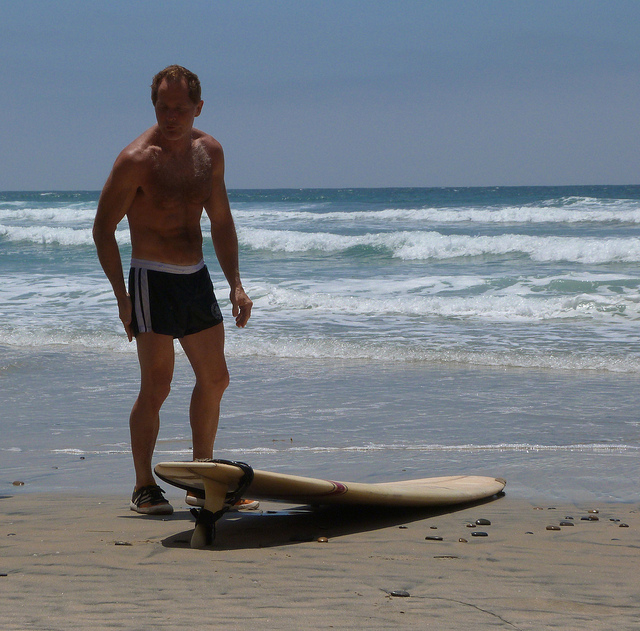Can you describe the surfboard's position relative to the man? The surfboard is positioned horizontally on the sandy beach to the man's right side, with the nose of the board pointing towards the sea and the tail end closer to the man. 